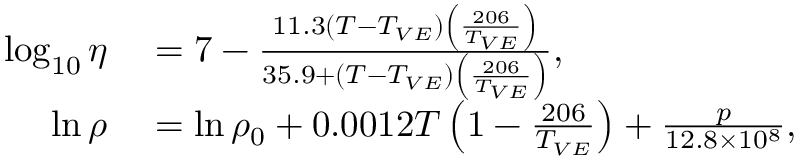Convert formula to latex. <formula><loc_0><loc_0><loc_500><loc_500>\begin{array} { r l } { \log _ { 1 0 } \eta } & = 7 - \frac { 1 1 . 3 \left ( T - T _ { V E } \right ) \left ( \frac { 2 0 6 } { T _ { V E } } \right ) } { 3 5 . 9 + \left ( T - T _ { V E } \right ) \left ( \frac { 2 0 6 } { T _ { V E } } \right ) } , } \\ { \ln \rho } & = \ln \rho _ { 0 } + 0 . 0 0 1 2 T \left ( 1 - \frac { 2 0 6 } { T _ { V E } } \right ) + \frac { p } { 1 2 . 8 \times 1 0 ^ { 8 } } , } \end{array}</formula> 